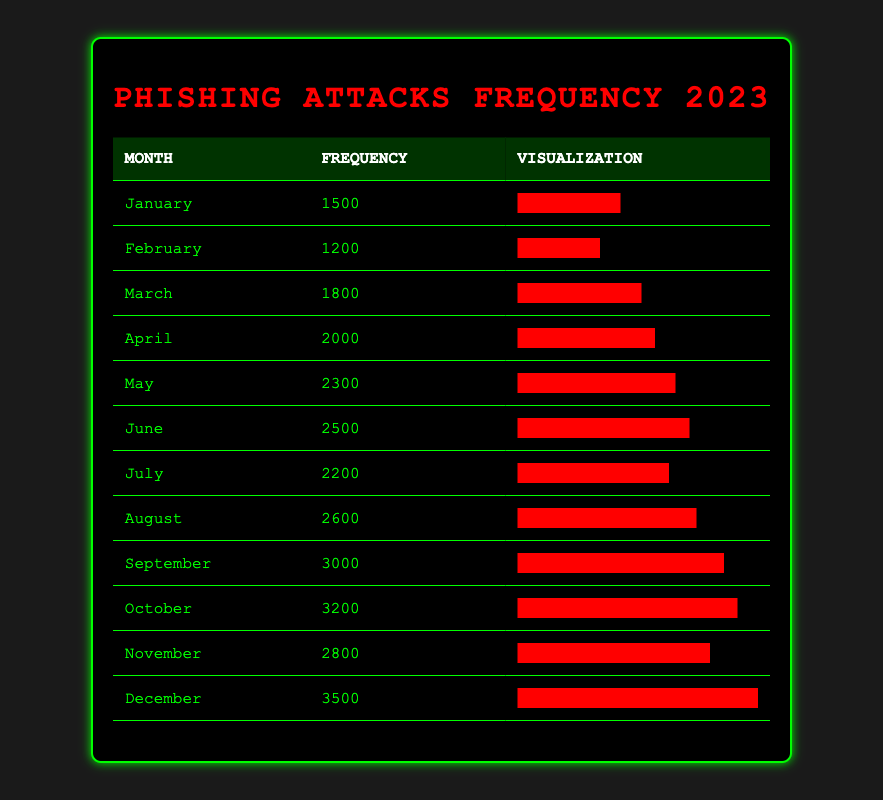What month had the highest frequency of phishing attacks? By examining the "Frequency" column in the table, it's clear that December has the highest value at 3500.
Answer: December What was the frequency of phishing attacks in March? Looking directly at the table for March, the frequency recorded is 1800.
Answer: 1800 What is the difference in frequency between January and June? January's frequency is 1500, and June's is 2500. The difference is calculated as 2500 - 1500 = 1000.
Answer: 1000 Did the frequency of phishing attacks increase from February to March? Comparing the frequencies, February has 1200 and March has 1800, indicating an increase.
Answer: Yes What is the average frequency of phishing attacks from January to April? The frequencies from January to April are 1500, 1200, 1800, and 2000. The sum of these values is 1500 + 1200 + 1800 + 2000 = 6500. There are 4 months, so the average is 6500 / 4 = 1625.
Answer: 1625 Which month experienced the lowest frequency of phishing attacks? By reviewing the "Frequency" column, February has the lowest value recorded at 1200.
Answer: February If you combine the frequencies of May and August, what is the total? The frequency for May is 2300 and for August is 2600. Adding these together gives 2300 + 2600 = 4900.
Answer: 4900 Were there any months with frequencies exceeding 3000? Checking the table reveals that October (3200) and December (3500) both exceed 3000.
Answer: Yes What was the percentage increase in frequency from September to October? The frequency in September is 3000, and in October, it is 3200. The increase is 3200 - 3000 = 200. To find the percentage increase, divide 200 by 3000 and multiply by 100, giving (200 / 3000) * 100 = 6.67%.
Answer: 6.67% 